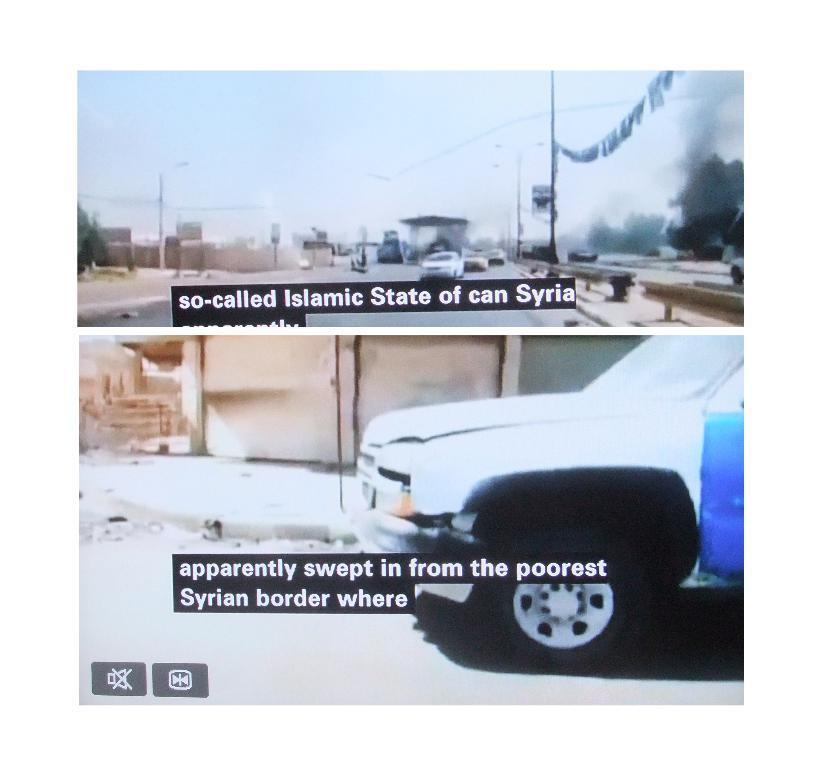Can you describe this image briefly? It is a collage image, there are two different pictures and there are some subtitles being displayed in each picture, it is regarding war in a country. In the first picture there is a road and few vehicles are moving on the road and in the second picture there is an image of a vehicle and behind the vehicle there is a wall. 